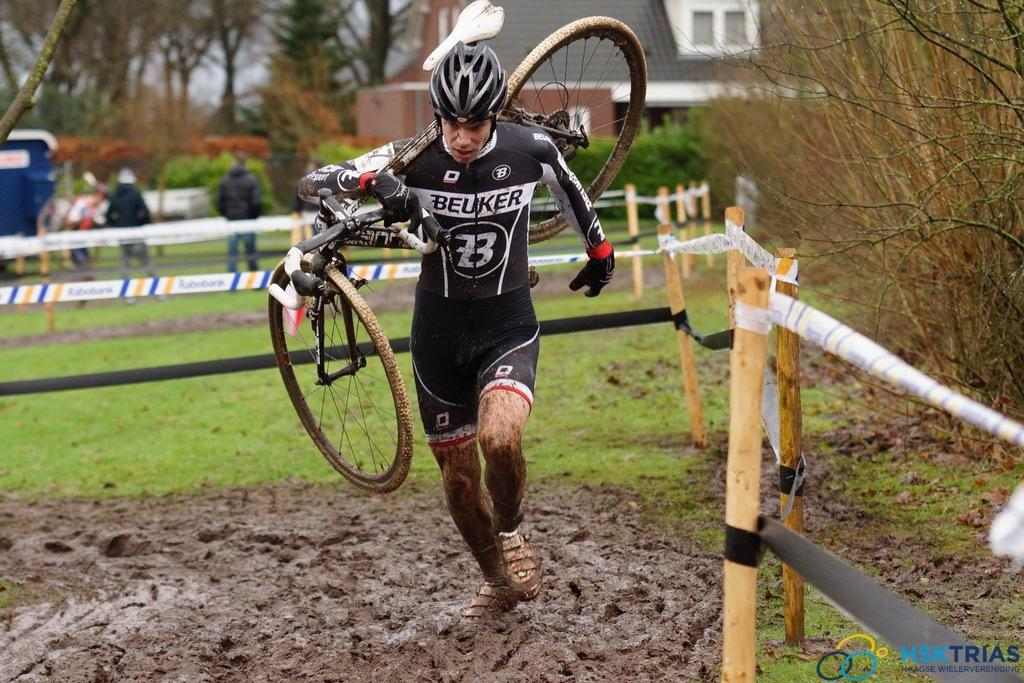<image>
Relay a brief, clear account of the picture shown. the number 23 that is on a person's outfit 